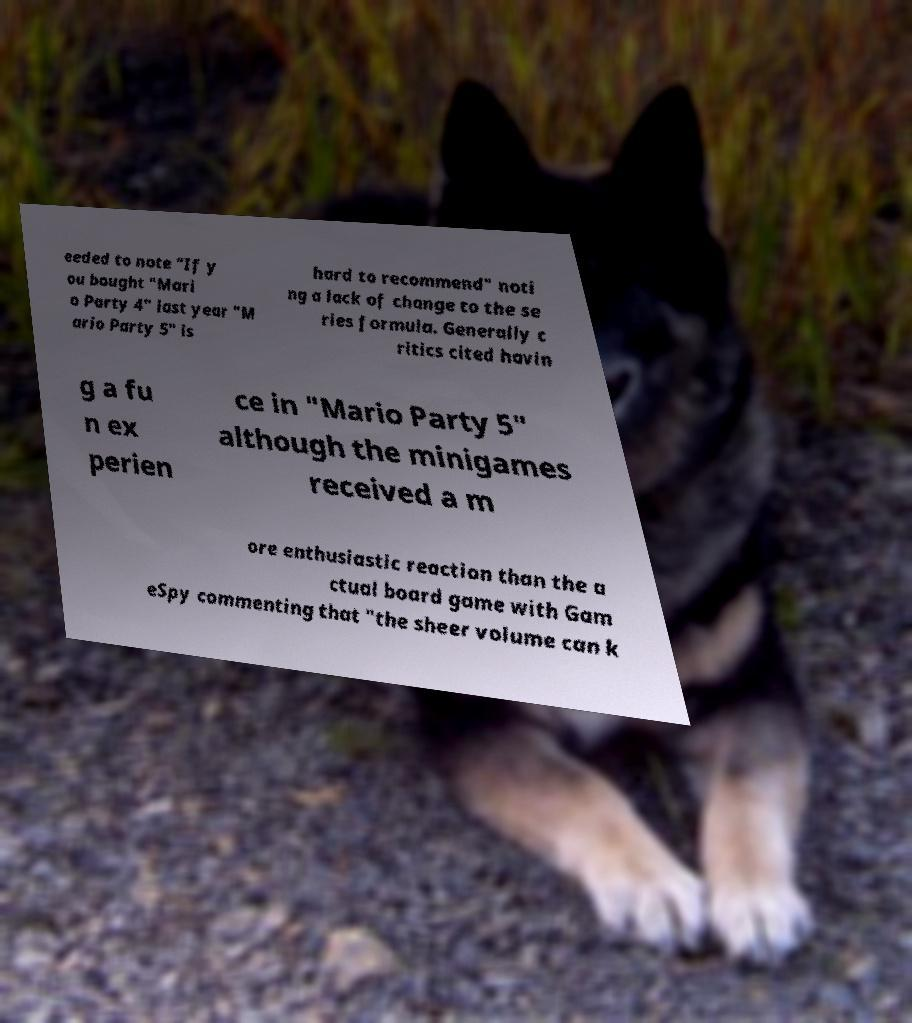Can you accurately transcribe the text from the provided image for me? eeded to note "If y ou bought "Mari o Party 4" last year "M ario Party 5" is hard to recommend" noti ng a lack of change to the se ries formula. Generally c ritics cited havin g a fu n ex perien ce in "Mario Party 5" although the minigames received a m ore enthusiastic reaction than the a ctual board game with Gam eSpy commenting that "the sheer volume can k 